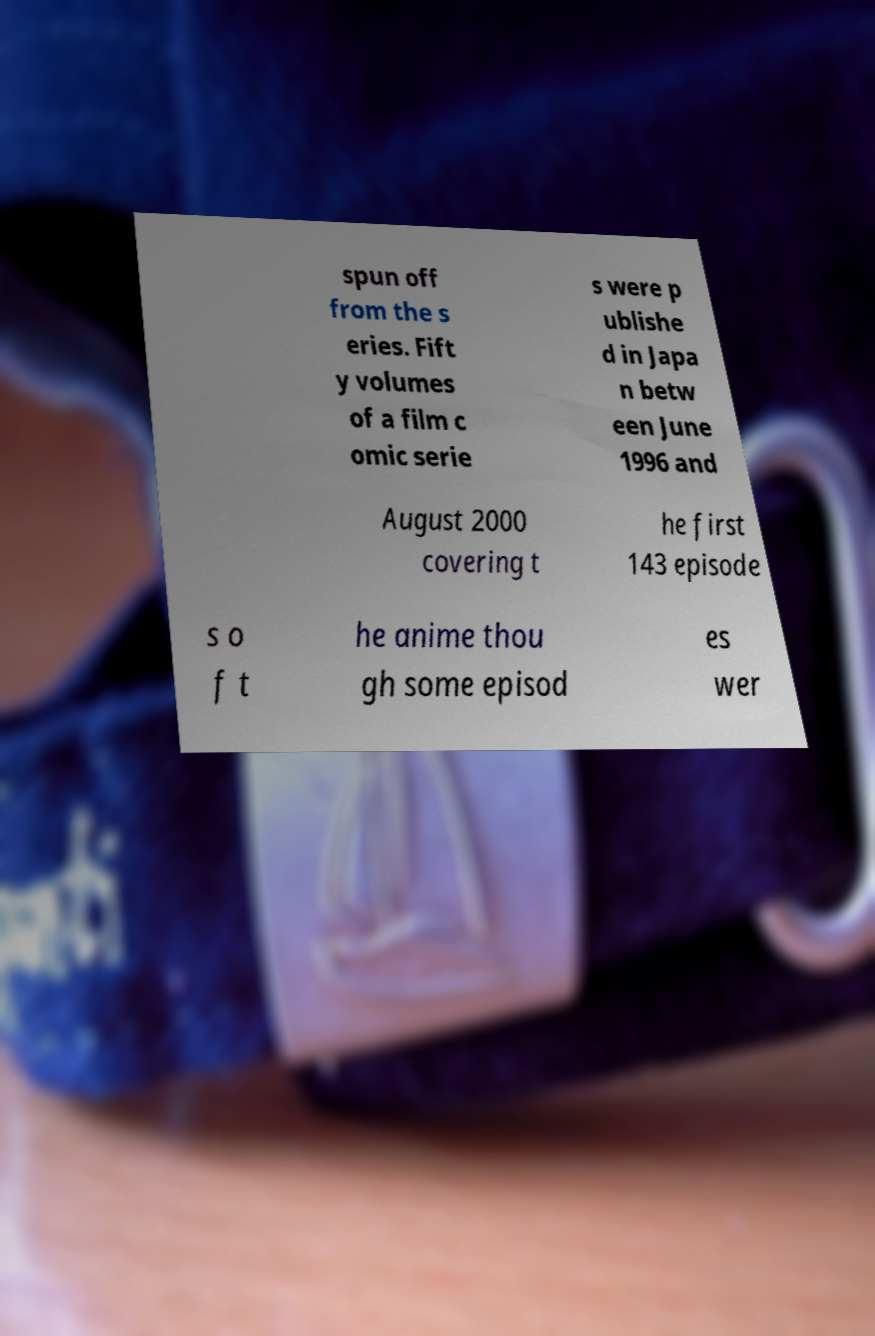What messages or text are displayed in this image? I need them in a readable, typed format. spun off from the s eries. Fift y volumes of a film c omic serie s were p ublishe d in Japa n betw een June 1996 and August 2000 covering t he first 143 episode s o f t he anime thou gh some episod es wer 